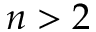Convert formula to latex. <formula><loc_0><loc_0><loc_500><loc_500>n > 2</formula> 